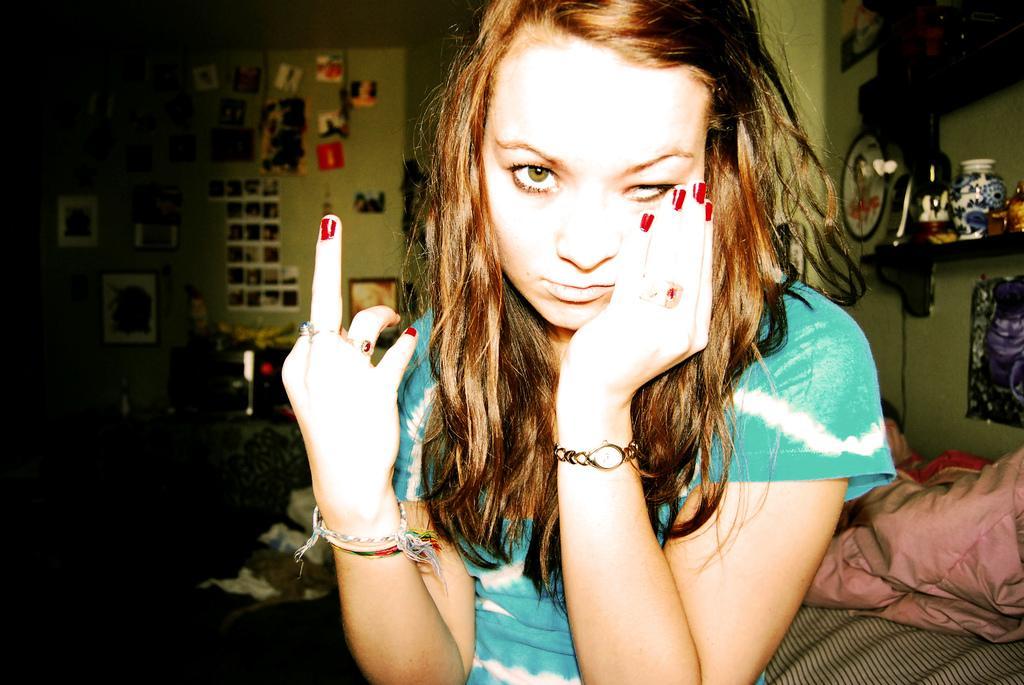Could you give a brief overview of what you see in this image? Here we can see a woman. There are clothes, bottle, and a jar. In the background we can see wall, frames, and posters. 